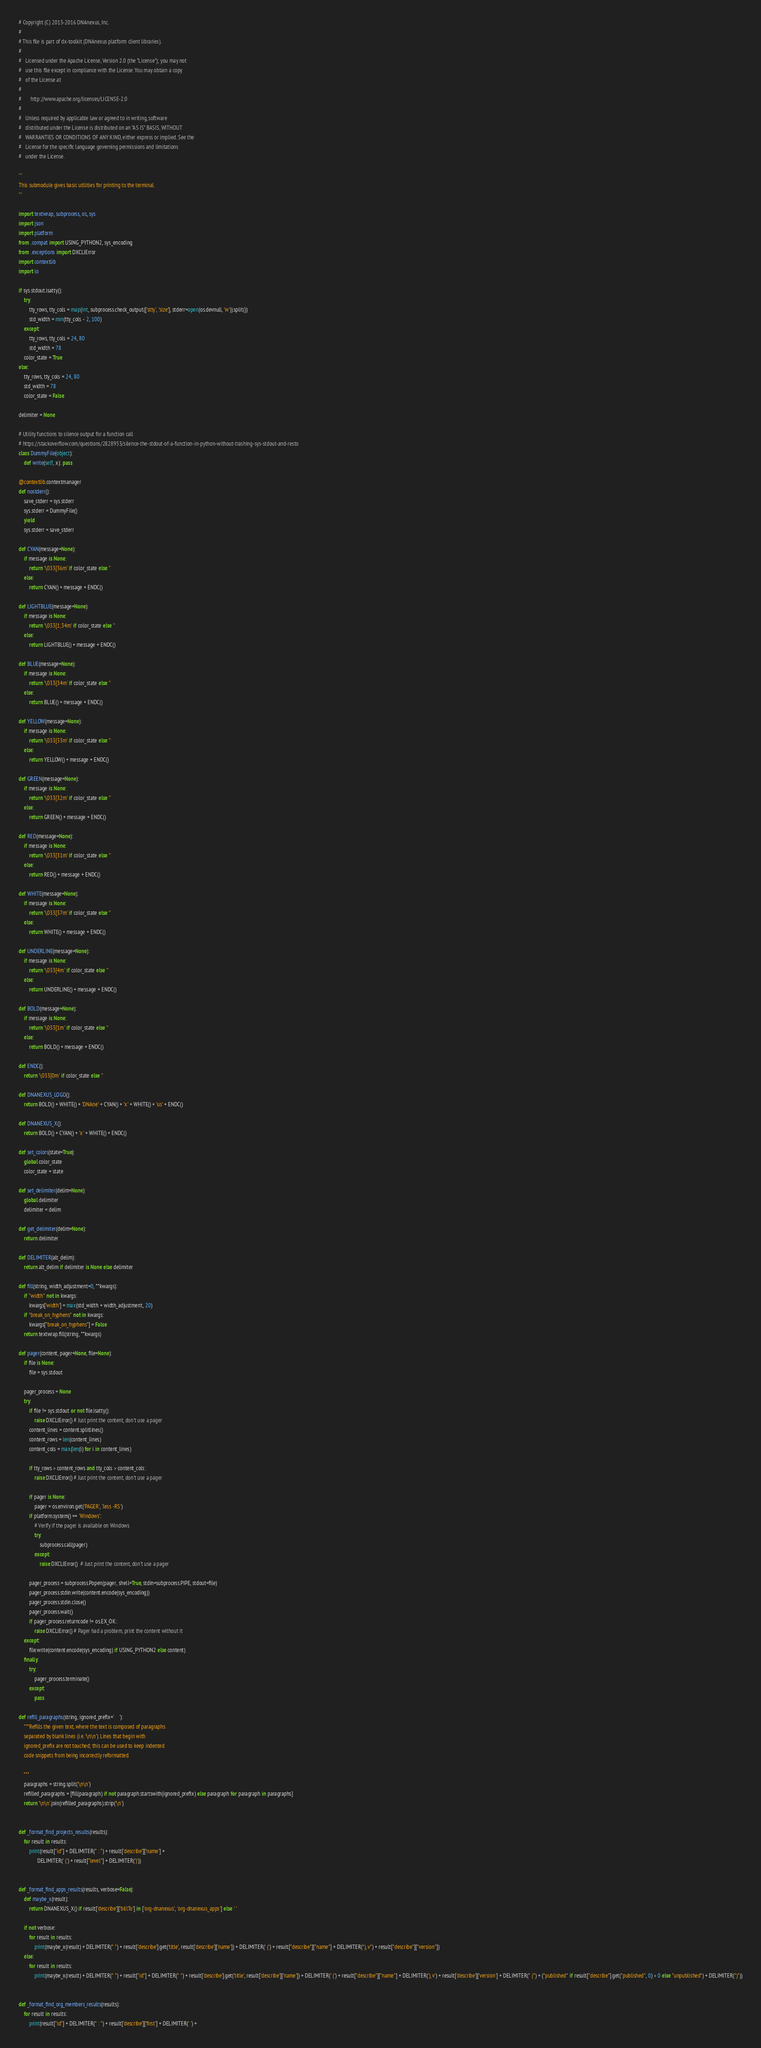<code> <loc_0><loc_0><loc_500><loc_500><_Python_># Copyright (C) 2013-2016 DNAnexus, Inc.
#
# This file is part of dx-toolkit (DNAnexus platform client libraries).
#
#   Licensed under the Apache License, Version 2.0 (the "License"); you may not
#   use this file except in compliance with the License. You may obtain a copy
#   of the License at
#
#       http://www.apache.org/licenses/LICENSE-2.0
#
#   Unless required by applicable law or agreed to in writing, software
#   distributed under the License is distributed on an "AS IS" BASIS, WITHOUT
#   WARRANTIES OR CONDITIONS OF ANY KIND, either express or implied. See the
#   License for the specific language governing permissions and limitations
#   under the License.

'''
This submodule gives basic utilities for printing to the terminal.
'''

import textwrap, subprocess, os, sys
import json
import platform
from ..compat import USING_PYTHON2, sys_encoding
from ..exceptions import DXCLIError
import contextlib
import io

if sys.stdout.isatty():
    try:
        tty_rows, tty_cols = map(int, subprocess.check_output(['stty', 'size'], stderr=open(os.devnull, 'w')).split())
        std_width = min(tty_cols - 2, 100)
    except:
        tty_rows, tty_cols = 24, 80
        std_width = 78
    color_state = True
else:
    tty_rows, tty_cols = 24, 80
    std_width = 78
    color_state = False

delimiter = None

# Utility functions to silence output for a function call
# https://stackoverflow.com/questions/2828953/silence-the-stdout-of-a-function-in-python-without-trashing-sys-stdout-and-resto
class DummyFile(object):
    def write(self, x): pass

@contextlib.contextmanager
def nostderr():
    save_stderr = sys.stderr
    sys.stderr = DummyFile()
    yield
    sys.stderr = save_stderr

def CYAN(message=None):
    if message is None:
        return '\033[36m' if color_state else ''
    else:
        return CYAN() + message + ENDC()

def LIGHTBLUE(message=None):
    if message is None:
        return '\033[1;34m' if color_state else ''
    else:
        return LIGHTBLUE() + message + ENDC()

def BLUE(message=None):
    if message is None:
        return '\033[34m' if color_state else ''
    else:
        return BLUE() + message + ENDC()

def YELLOW(message=None):
    if message is None:
        return '\033[33m' if color_state else ''
    else:
        return YELLOW() + message + ENDC()

def GREEN(message=None):
    if message is None:
        return '\033[32m' if color_state else ''
    else:
        return GREEN() + message + ENDC()

def RED(message=None):
    if message is None:
        return '\033[31m' if color_state else ''
    else:
        return RED() + message + ENDC()

def WHITE(message=None):
    if message is None:
        return '\033[37m' if color_state else ''
    else:
        return WHITE() + message + ENDC()

def UNDERLINE(message=None):
    if message is None:
        return '\033[4m' if color_state else ''
    else:
        return UNDERLINE() + message + ENDC()

def BOLD(message=None):
    if message is None:
        return '\033[1m' if color_state else ''
    else:
        return BOLD() + message + ENDC()

def ENDC():
    return '\033[0m' if color_state else ''

def DNANEXUS_LOGO():
    return BOLD() + WHITE() + 'DNAne' + CYAN() + 'x' + WHITE() + 'us' + ENDC()

def DNANEXUS_X():
    return BOLD() + CYAN() + 'x' + WHITE() + ENDC()

def set_colors(state=True):
    global color_state
    color_state = state

def set_delimiter(delim=None):
    global delimiter
    delimiter = delim

def get_delimiter(delim=None):
    return delimiter

def DELIMITER(alt_delim):
    return alt_delim if delimiter is None else delimiter

def fill(string, width_adjustment=0, **kwargs):
    if "width" not in kwargs:
        kwargs['width'] = max(std_width + width_adjustment, 20)
    if "break_on_hyphens" not in kwargs:
        kwargs["break_on_hyphens"] = False
    return textwrap.fill(string, **kwargs)

def pager(content, pager=None, file=None):
    if file is None:
        file = sys.stdout

    pager_process = None
    try:
        if file != sys.stdout or not file.isatty():
            raise DXCLIError() # Just print the content, don't use a pager
        content_lines = content.splitlines()
        content_rows = len(content_lines)
        content_cols = max(len(i) for i in content_lines)

        if tty_rows > content_rows and tty_cols > content_cols:
            raise DXCLIError() # Just print the content, don't use a pager

        if pager is None:
            pager = os.environ.get('PAGER', 'less -RS')
        if platform.system() == 'Windows':
            # Verify if the pager is available on Windows
            try:
                subprocess.call(pager)
            except:
                raise DXCLIError()  # Just print the content, don't use a pager

        pager_process = subprocess.Popen(pager, shell=True, stdin=subprocess.PIPE, stdout=file)
        pager_process.stdin.write(content.encode(sys_encoding))
        pager_process.stdin.close()
        pager_process.wait()
        if pager_process.returncode != os.EX_OK:
            raise DXCLIError() # Pager had a problem, print the content without it
    except:
        file.write(content.encode(sys_encoding) if USING_PYTHON2 else content)
    finally:
        try:
            pager_process.terminate()
        except:
            pass

def refill_paragraphs(string, ignored_prefix='    '):
    """Refills the given text, where the text is composed of paragraphs
    separated by blank lines (i.e. '\n\n'). Lines that begin with
    ignored_prefix are not touched; this can be used to keep indented
    code snippets from being incorrectly reformatted.

    """
    paragraphs = string.split('\n\n')
    refilled_paragraphs = [fill(paragraph) if not paragraph.startswith(ignored_prefix) else paragraph for paragraph in paragraphs]
    return '\n\n'.join(refilled_paragraphs).strip('\n')


def _format_find_projects_results(results):
    for result in results:
        print(result["id"] + DELIMITER(" : ") + result['describe']['name'] +
              DELIMITER(' (') + result["level"] + DELIMITER(')'))


def _format_find_apps_results(results, verbose=False):
    def maybe_x(result):
        return DNANEXUS_X() if result['describe']['billTo'] in ['org-dnanexus', 'org-dnanexus_apps'] else ' '

    if not verbose:
        for result in results:
            print(maybe_x(result) + DELIMITER(" ") + result['describe'].get('title', result['describe']['name']) + DELIMITER(' (') + result["describe"]["name"] + DELIMITER("), v") + result["describe"]["version"])
    else:
        for result in results:
            print(maybe_x(result) + DELIMITER(" ") + result["id"] + DELIMITER(" ") + result['describe'].get('title', result['describe']['name']) + DELIMITER(' (') + result["describe"]["name"] + DELIMITER('), v') + result['describe']['version'] + DELIMITER(" (") + ("published" if result["describe"].get("published", 0) > 0 else "unpublished") + DELIMITER(")"))


def _format_find_org_members_results(results):
    for result in results:
        print(result["id"] + DELIMITER(" : ") + result['describe']['first'] + DELIMITER(' ') +</code> 